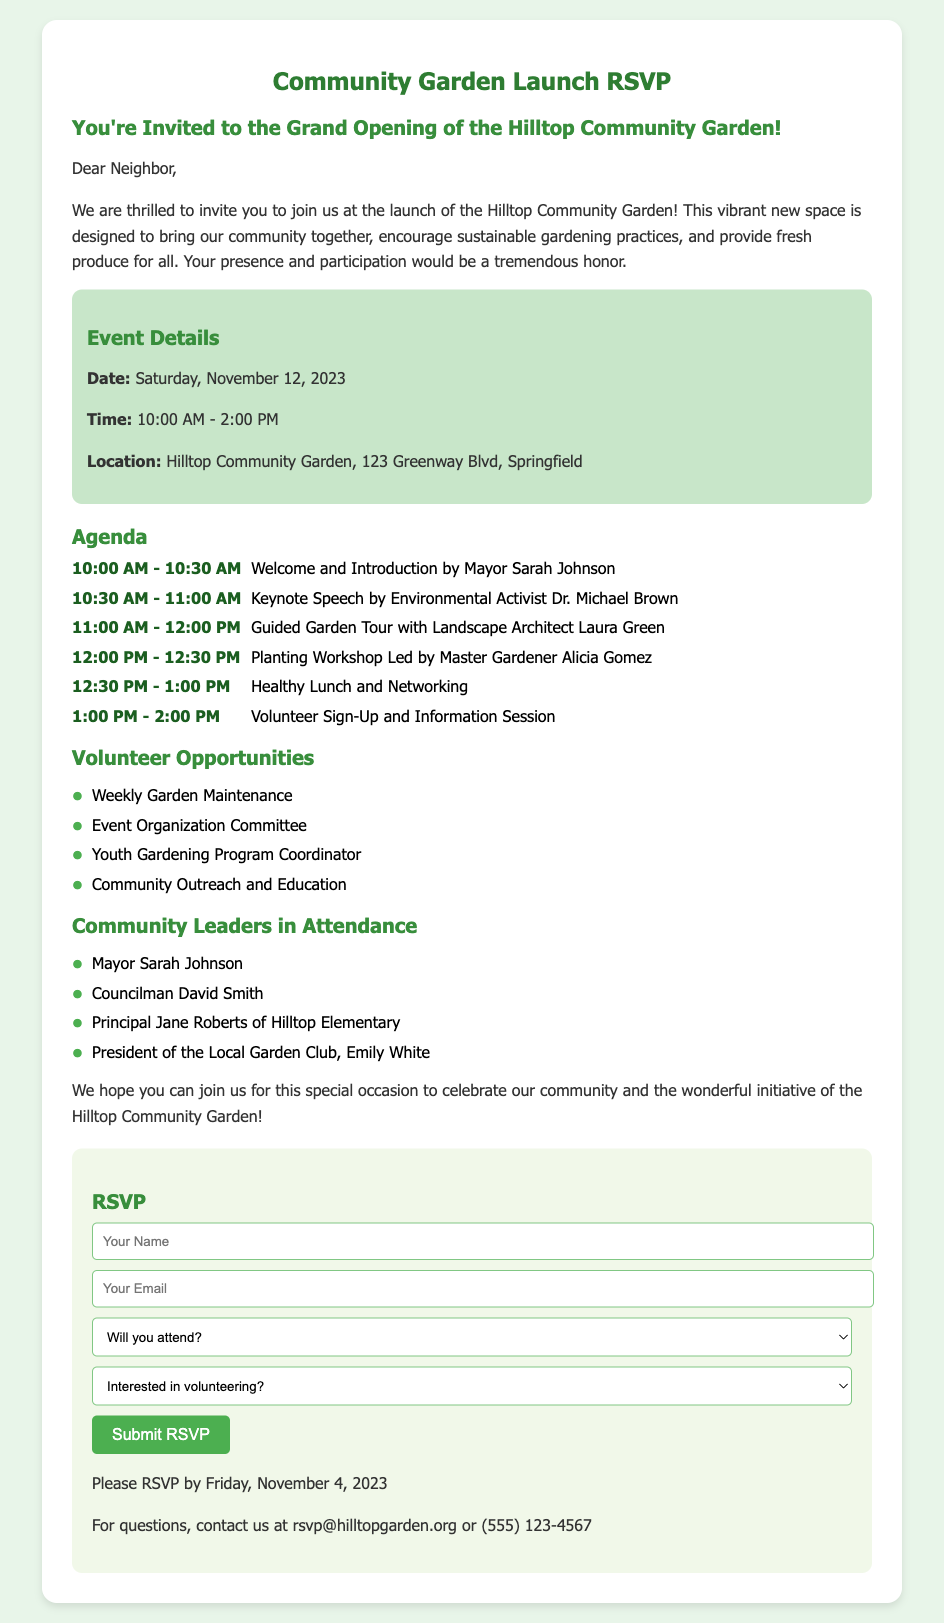What is the date of the Community Garden launch? The date is mentioned in the Event Details section of the document.
Answer: Saturday, November 12, 2023 Who is giving the keynote speech? The document lists the speakers in the Agenda section.
Answer: Dr. Michael Brown What time does the event start? The start time can be found in the Event Details section.
Answer: 10:00 AM What volunteer opportunity is available related to youth? Volunteer opportunities are listed in a dedicated section of the document.
Answer: Youth Gardening Program Coordinator How can you RSVP for the event? The RSVP section provides the method for responding to the invitation.
Answer: Submit the RSVP form What is the deadline to RSVP? The document specifies the deadline in the RSVP section.
Answer: Friday, November 4, 2023 Who is the principal attending the event? The list of community leaders includes titles and names.
Answer: Principal Jane Roberts What type of workshop will be led by Alicia Gomez? The Agenda section outlines the activities scheduled for the event.
Answer: Planting Workshop What is the address of the Hilltop Community Garden? The location is included in the Event Details section.
Answer: 123 Greenway Blvd, Springfield 